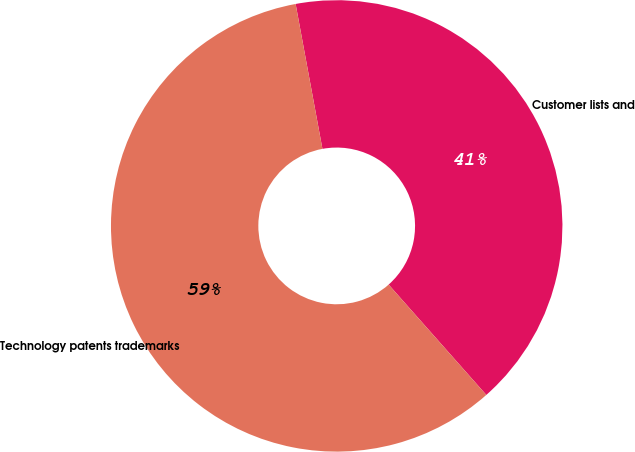<chart> <loc_0><loc_0><loc_500><loc_500><pie_chart><fcel>Customer lists and<fcel>Technology patents trademarks<nl><fcel>41.38%<fcel>58.62%<nl></chart> 